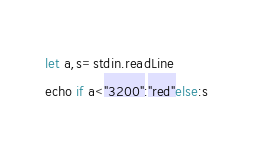Convert code to text. <code><loc_0><loc_0><loc_500><loc_500><_Nim_>let a,s=stdin.readLine
echo if a<"3200":"red"else:s</code> 